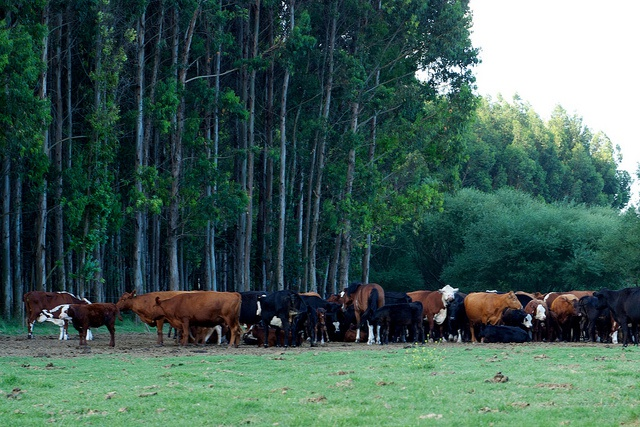Describe the objects in this image and their specific colors. I can see cow in black, gray, navy, and darkgray tones, cow in black, maroon, and brown tones, cow in black, darkgray, gray, and navy tones, cow in black, navy, gray, and blue tones, and cow in black, maroon, gray, and lightgray tones in this image. 